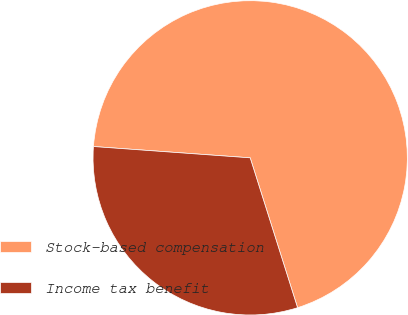Convert chart to OTSL. <chart><loc_0><loc_0><loc_500><loc_500><pie_chart><fcel>Stock-based compensation<fcel>Income tax benefit<nl><fcel>68.98%<fcel>31.02%<nl></chart> 